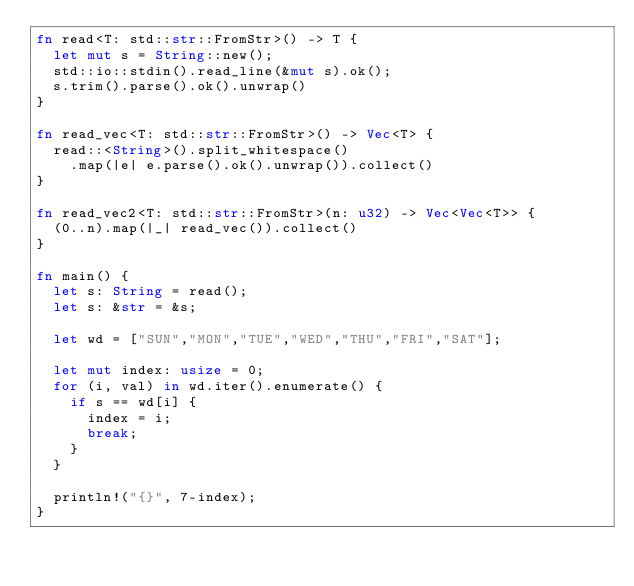Convert code to text. <code><loc_0><loc_0><loc_500><loc_500><_Rust_>fn read<T: std::str::FromStr>() -> T {
  let mut s = String::new();
  std::io::stdin().read_line(&mut s).ok();
  s.trim().parse().ok().unwrap()
}

fn read_vec<T: std::str::FromStr>() -> Vec<T> {
  read::<String>().split_whitespace()
    .map(|e| e.parse().ok().unwrap()).collect()
}

fn read_vec2<T: std::str::FromStr>(n: u32) -> Vec<Vec<T>> {
  (0..n).map(|_| read_vec()).collect()
}

fn main() {
  let s: String = read();
  let s: &str = &s;

  let wd = ["SUN","MON","TUE","WED","THU","FRI","SAT"];

  let mut index: usize = 0;
  for (i, val) in wd.iter().enumerate() {
    if s == wd[i] {
      index = i;
      break;
    }
  }

  println!("{}", 7-index);
}</code> 